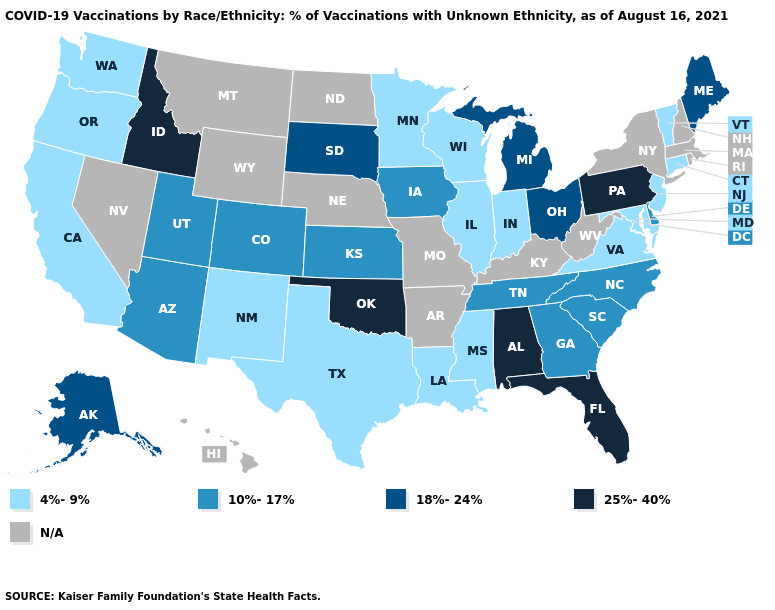Does Mississippi have the lowest value in the USA?
Concise answer only. Yes. Among the states that border Nevada , does Idaho have the highest value?
Be succinct. Yes. Name the states that have a value in the range N/A?
Give a very brief answer. Arkansas, Hawaii, Kentucky, Massachusetts, Missouri, Montana, Nebraska, Nevada, New Hampshire, New York, North Dakota, Rhode Island, West Virginia, Wyoming. Name the states that have a value in the range 18%-24%?
Short answer required. Alaska, Maine, Michigan, Ohio, South Dakota. What is the value of Missouri?
Short answer required. N/A. What is the value of Nevada?
Short answer required. N/A. Which states have the lowest value in the West?
Concise answer only. California, New Mexico, Oregon, Washington. Which states have the highest value in the USA?
Short answer required. Alabama, Florida, Idaho, Oklahoma, Pennsylvania. Name the states that have a value in the range 25%-40%?
Give a very brief answer. Alabama, Florida, Idaho, Oklahoma, Pennsylvania. Name the states that have a value in the range 10%-17%?
Give a very brief answer. Arizona, Colorado, Delaware, Georgia, Iowa, Kansas, North Carolina, South Carolina, Tennessee, Utah. Does Maine have the lowest value in the Northeast?
Concise answer only. No. Name the states that have a value in the range 4%-9%?
Give a very brief answer. California, Connecticut, Illinois, Indiana, Louisiana, Maryland, Minnesota, Mississippi, New Jersey, New Mexico, Oregon, Texas, Vermont, Virginia, Washington, Wisconsin. What is the value of Michigan?
Give a very brief answer. 18%-24%. Does the map have missing data?
Write a very short answer. Yes. Does Idaho have the highest value in the West?
Quick response, please. Yes. 